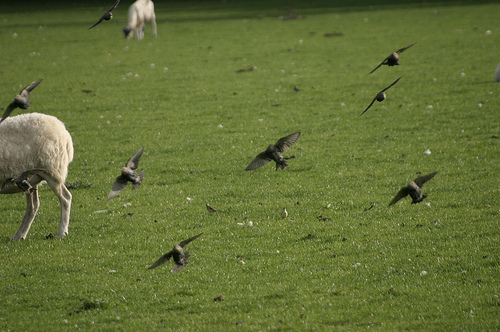Describe the overall scene depicted in this image. The image captures a pastoral scene with several birds in various stages of flight and a sheep grazing peacefully in the background. The interaction between airborne wildlife and the tranquil setting emphasizes a harmonious natural environment. 